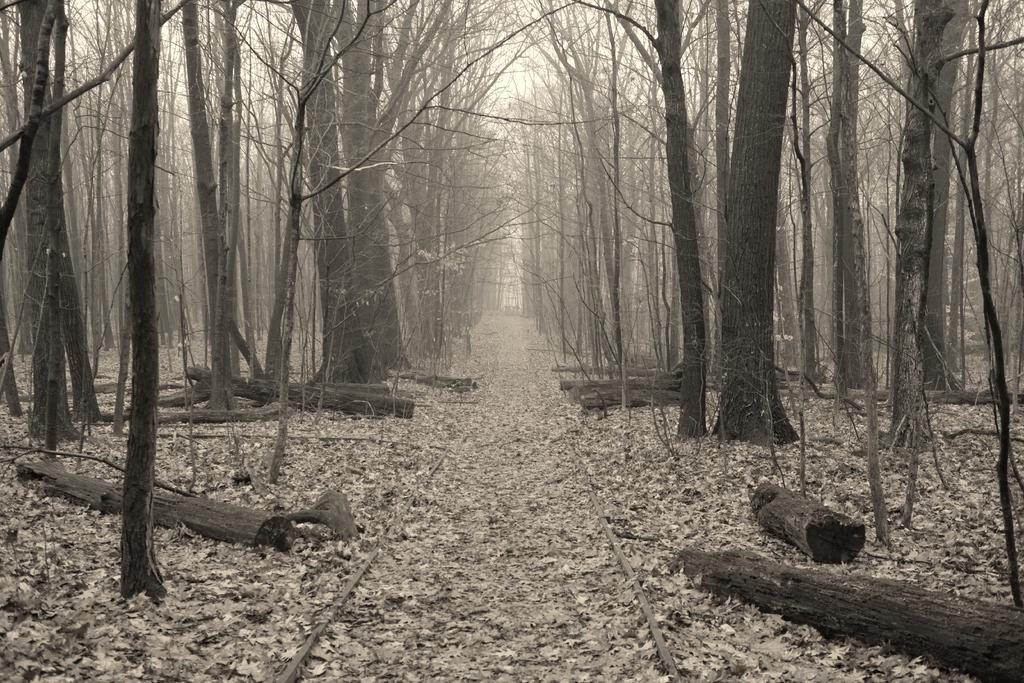What type of vegetation is present in the image? There are many trees in the image. What can be seen at the bottom of the image? There is a track, dry leaves, and wooden logs visible at the bottom of the image. What is visible in the background of the image? The sky is visible in the background of the image. How many questions are asked in the image? There is no indication of any questions being asked in the image. What day of the week is depicted in the image? The image does not depict a specific day of the week. Are there any roses visible in the image? There are no roses present in the image. 